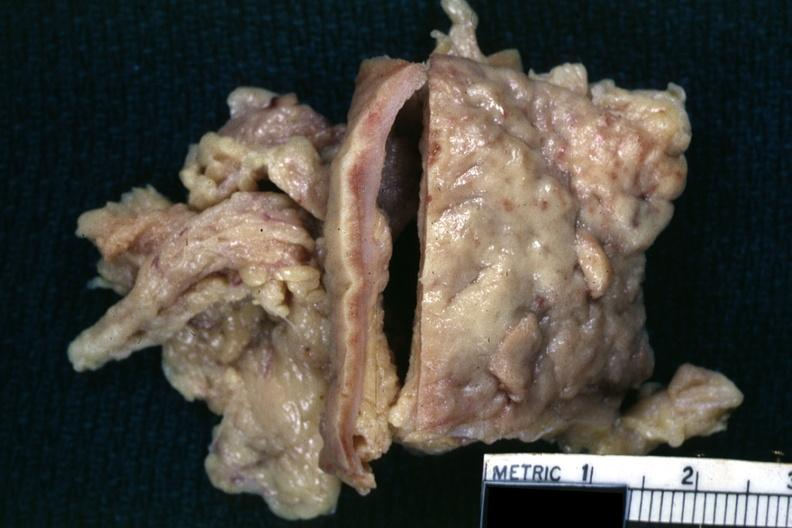what is present?
Answer the question using a single word or phrase. Abdomen 